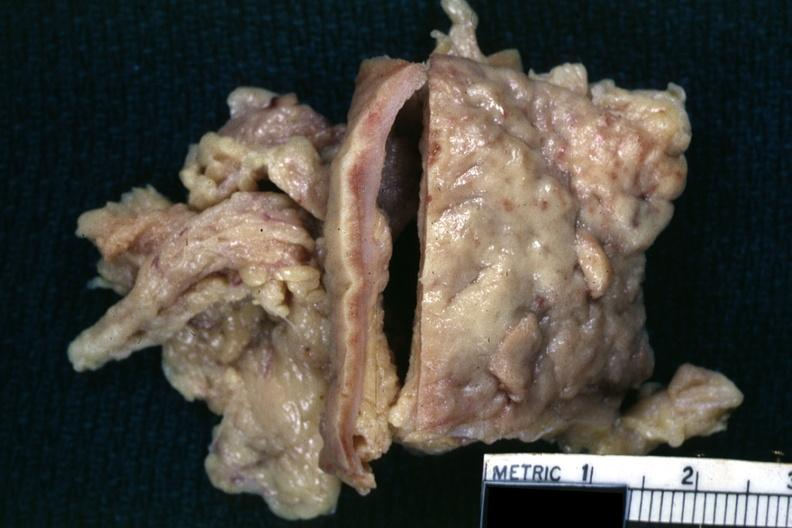what is present?
Answer the question using a single word or phrase. Abdomen 